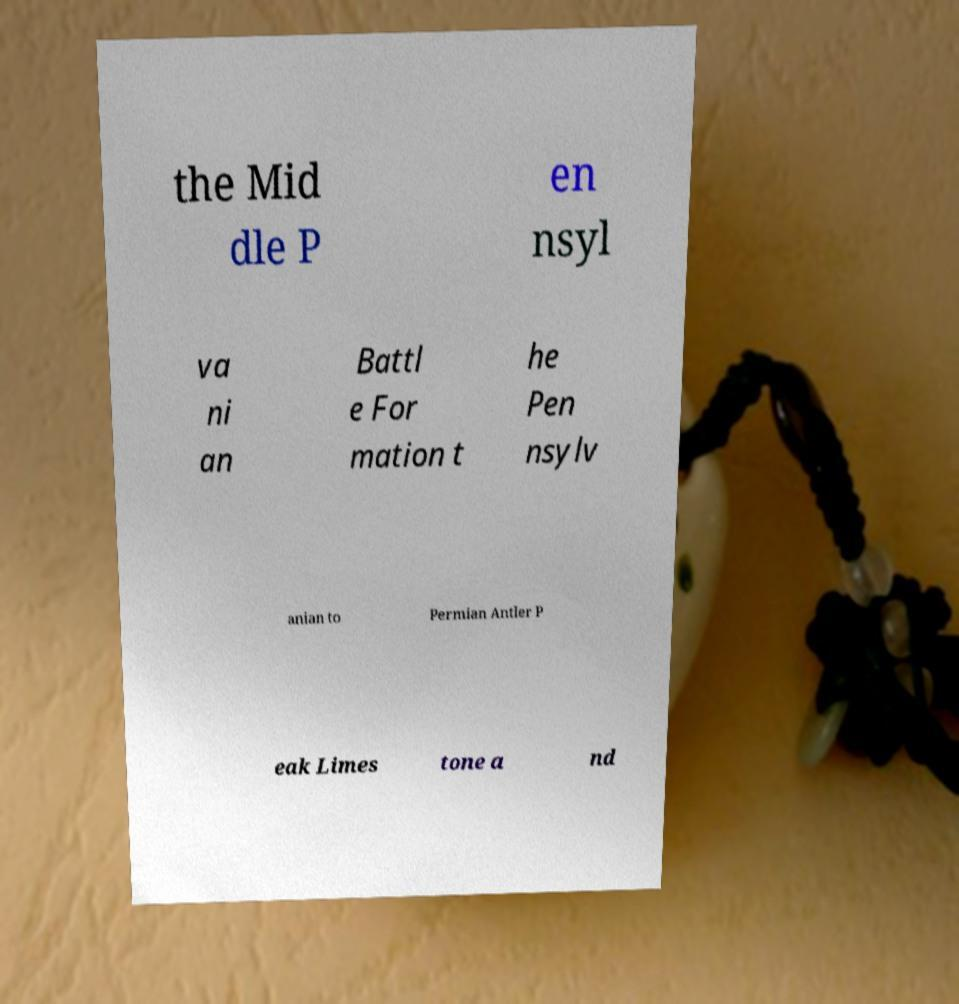What messages or text are displayed in this image? I need them in a readable, typed format. the Mid dle P en nsyl va ni an Battl e For mation t he Pen nsylv anian to Permian Antler P eak Limes tone a nd 